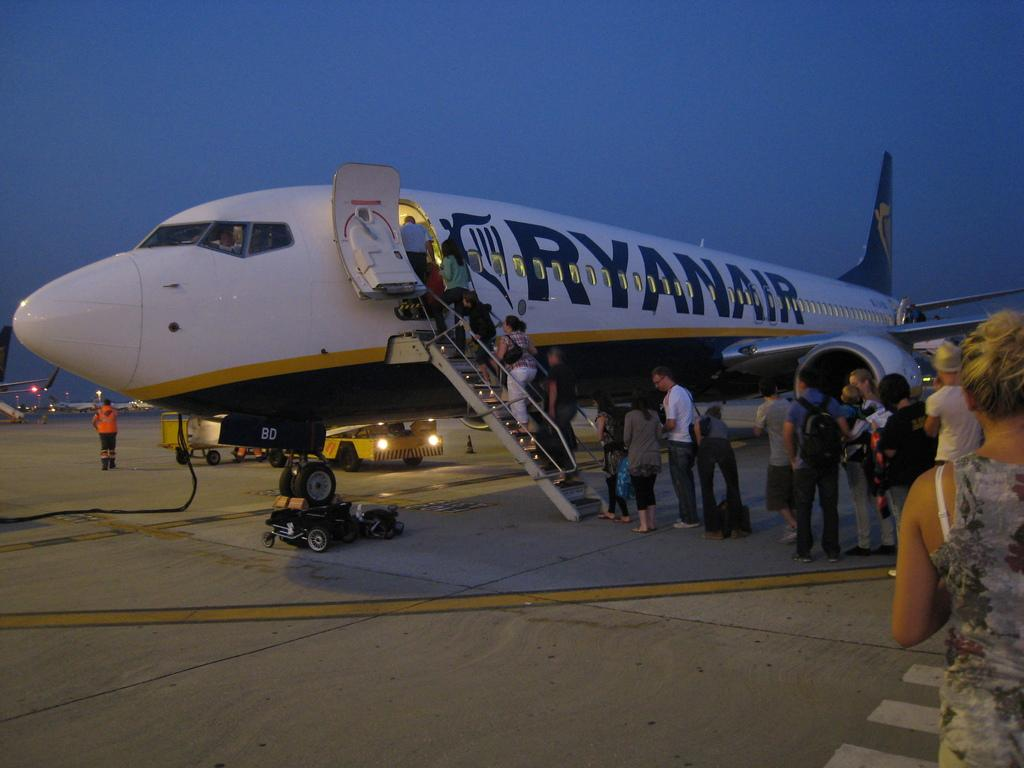Who or what can be seen in the image? There are people in the image. What else is present in the image besides the people? There is a plane and a vehicle in the image. What is the color of the sky in the image? The sky is blue in the image. Can you tell me how many mittens are being worn by the people in the image? There is no mention of mittens in the image, so it is not possible to determine if any are being worn. 